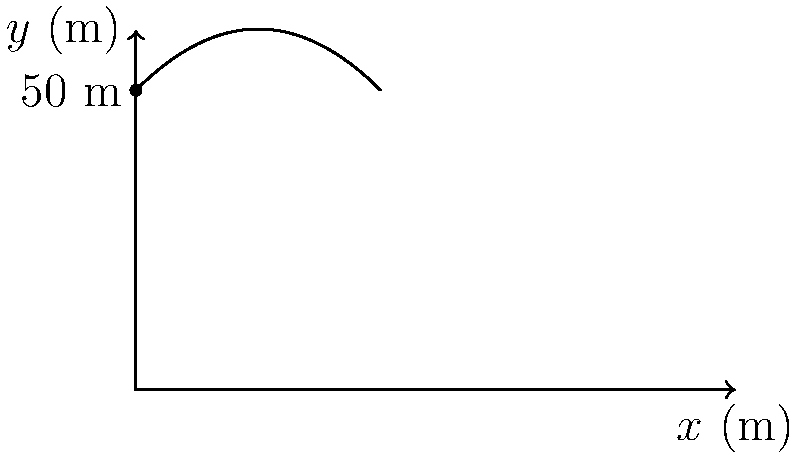As a successful entrepreneur, you often reflect on the problem-solving skills you learned in Gerald's physics class. Consider a projectile launched from a cliff 50 meters high with an initial velocity of 20 m/s at an angle of 45° above the horizontal. What is the maximum height reached by the projectile above the ground? Let's approach this step-by-step:

1) First, recall the equation for the y-position of a projectile:
   $$y(t) = y_0 + v_0y \cdot t - \frac{1}{2}gt^2$$
   where $y_0$ is the initial height, $v_0y$ is the initial vertical velocity, $g$ is the acceleration due to gravity, and $t$ is time.

2) We're given:
   - Initial height $y_0 = 50$ m
   - Initial velocity $v_0 = 20$ m/s
   - Launch angle $\theta = 45°$
   - $g = 9.8$ m/s²

3) Calculate the initial vertical velocity:
   $$v_0y = v_0 \sin(\theta) = 20 \sin(45°) = 20 \cdot \frac{\sqrt{2}}{2} \approx 14.14 \text{ m/s}$$

4) The maximum height is reached when the vertical velocity becomes zero. We can find this time:
   $$0 = v_0y - gt_\text{max}$$
   $$t_\text{max} = \frac{v_0y}{g} = \frac{14.14}{9.8} \approx 1.44 \text{ s}$$

5) Now, plug this time back into the y-position equation:
   $$y_\text{max} = 50 + 14.14 \cdot 1.44 - \frac{1}{2} \cdot 9.8 \cdot 1.44^2$$
   $$y_\text{max} = 50 + 20.36 - 10.18 \approx 60.18 \text{ m}$$

Thus, the maximum height reached is approximately 60.18 meters above the ground.
Answer: 60.18 meters 